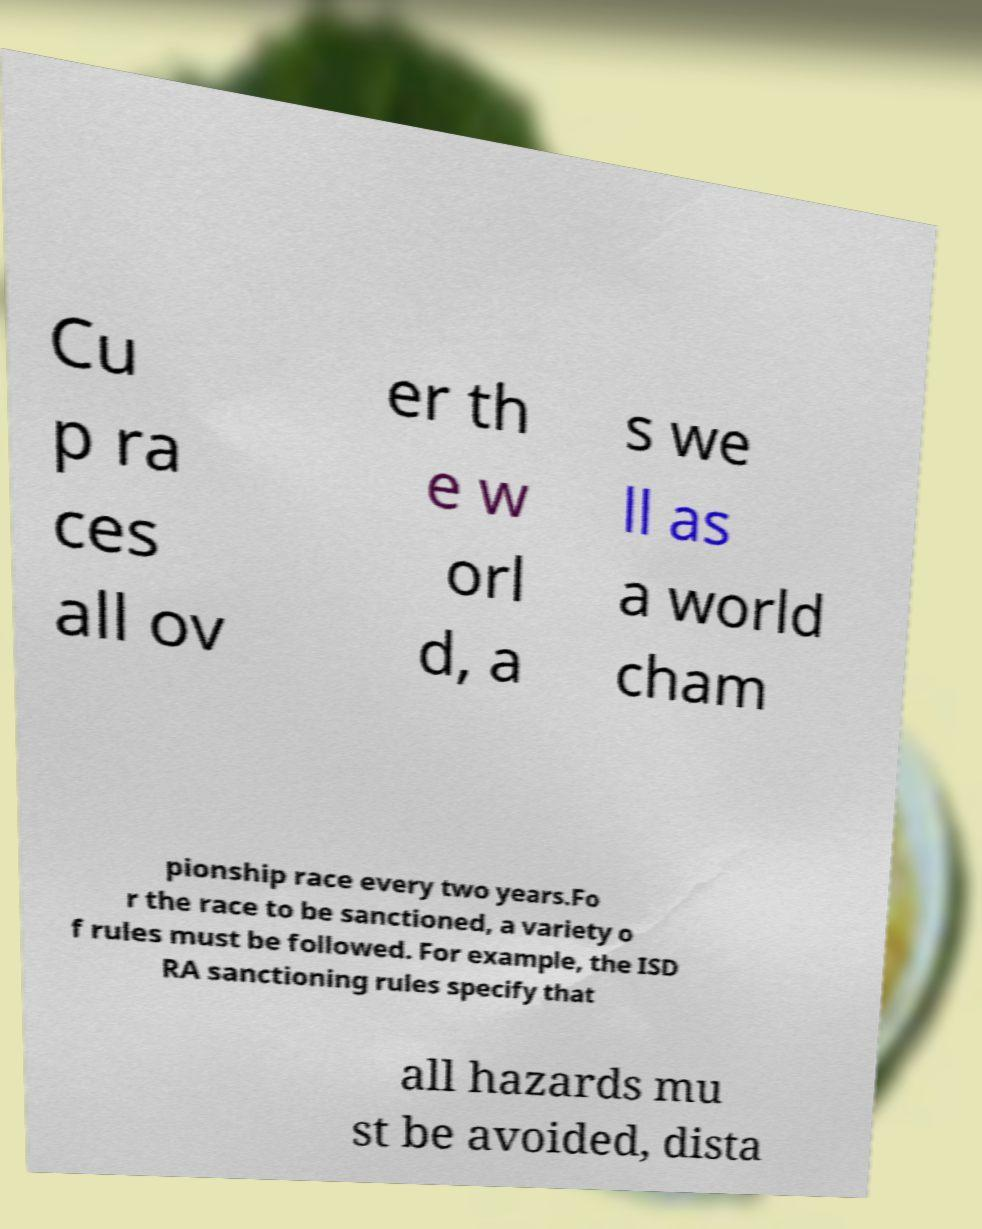There's text embedded in this image that I need extracted. Can you transcribe it verbatim? Cu p ra ces all ov er th e w orl d, a s we ll as a world cham pionship race every two years.Fo r the race to be sanctioned, a variety o f rules must be followed. For example, the ISD RA sanctioning rules specify that all hazards mu st be avoided, dista 